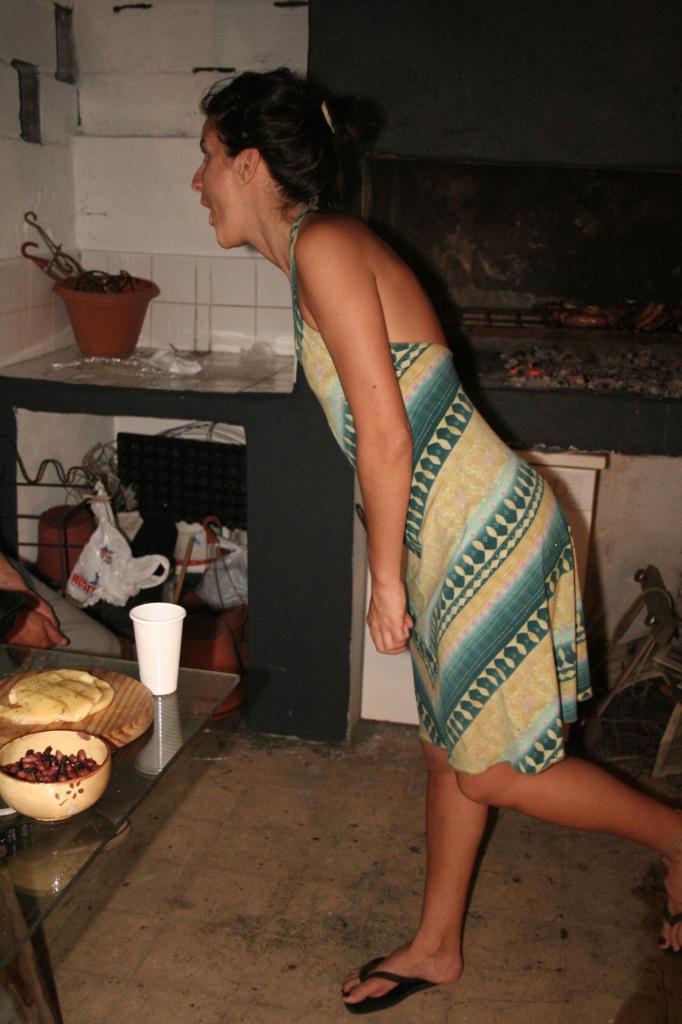In one or two sentences, can you explain what this image depicts? In this image we can see a woman wearing a dress is standing on the ground. To the left side of the image we can see a person, group of bowls containing food and glass placed on the table. In the background, we can see a pot placed on the countertop and some objects is placed on the table. 